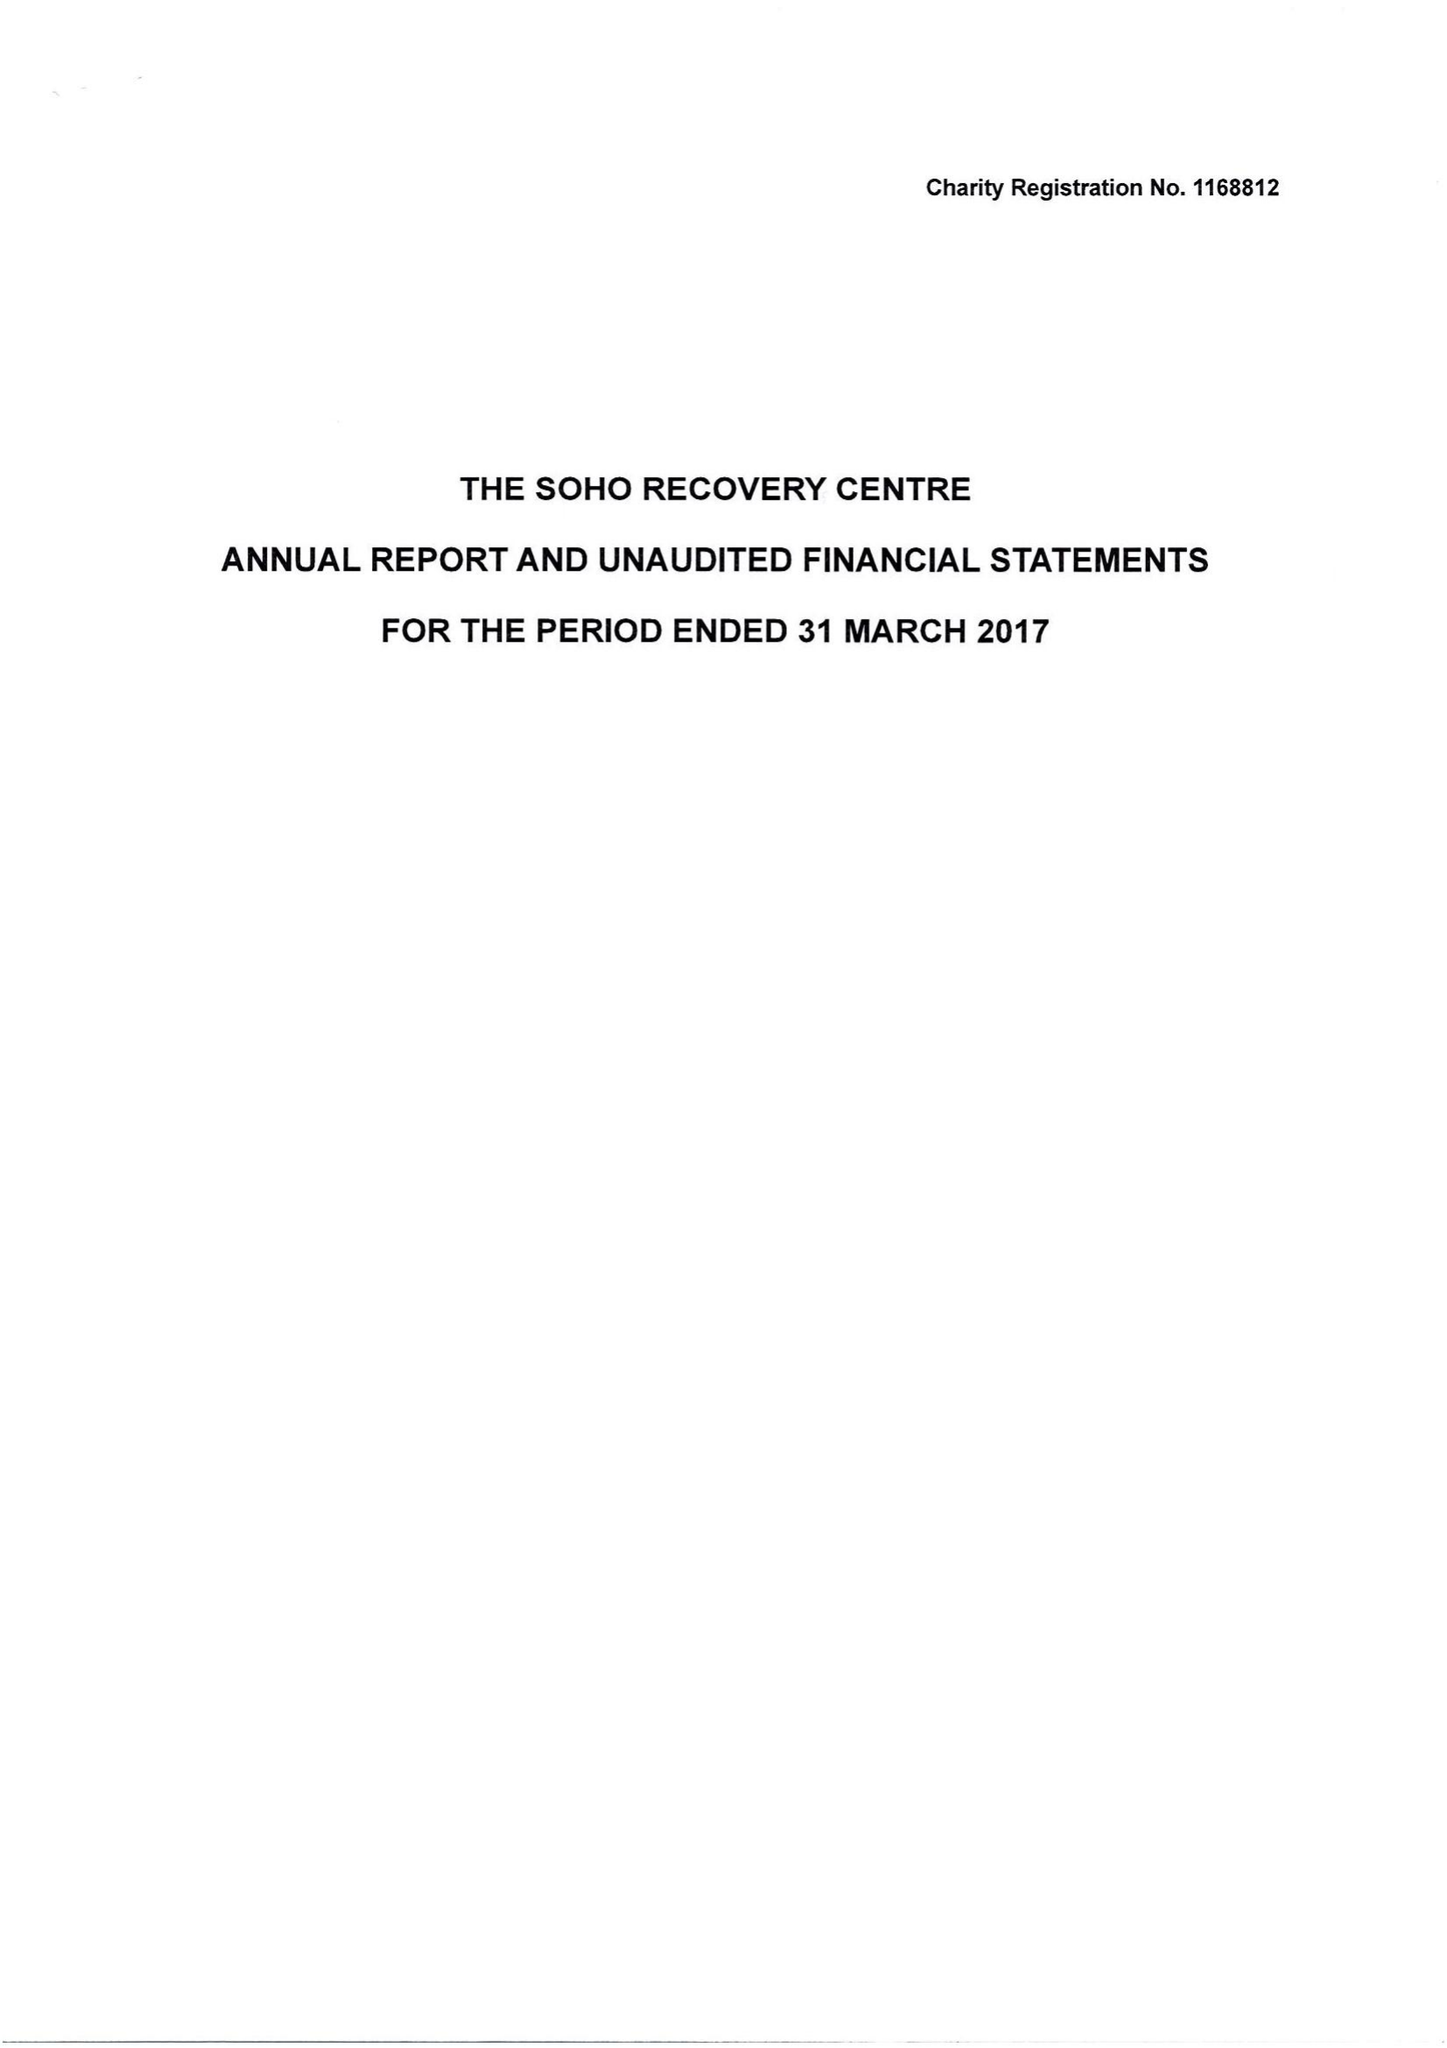What is the value for the charity_number?
Answer the question using a single word or phrase. 1168812 